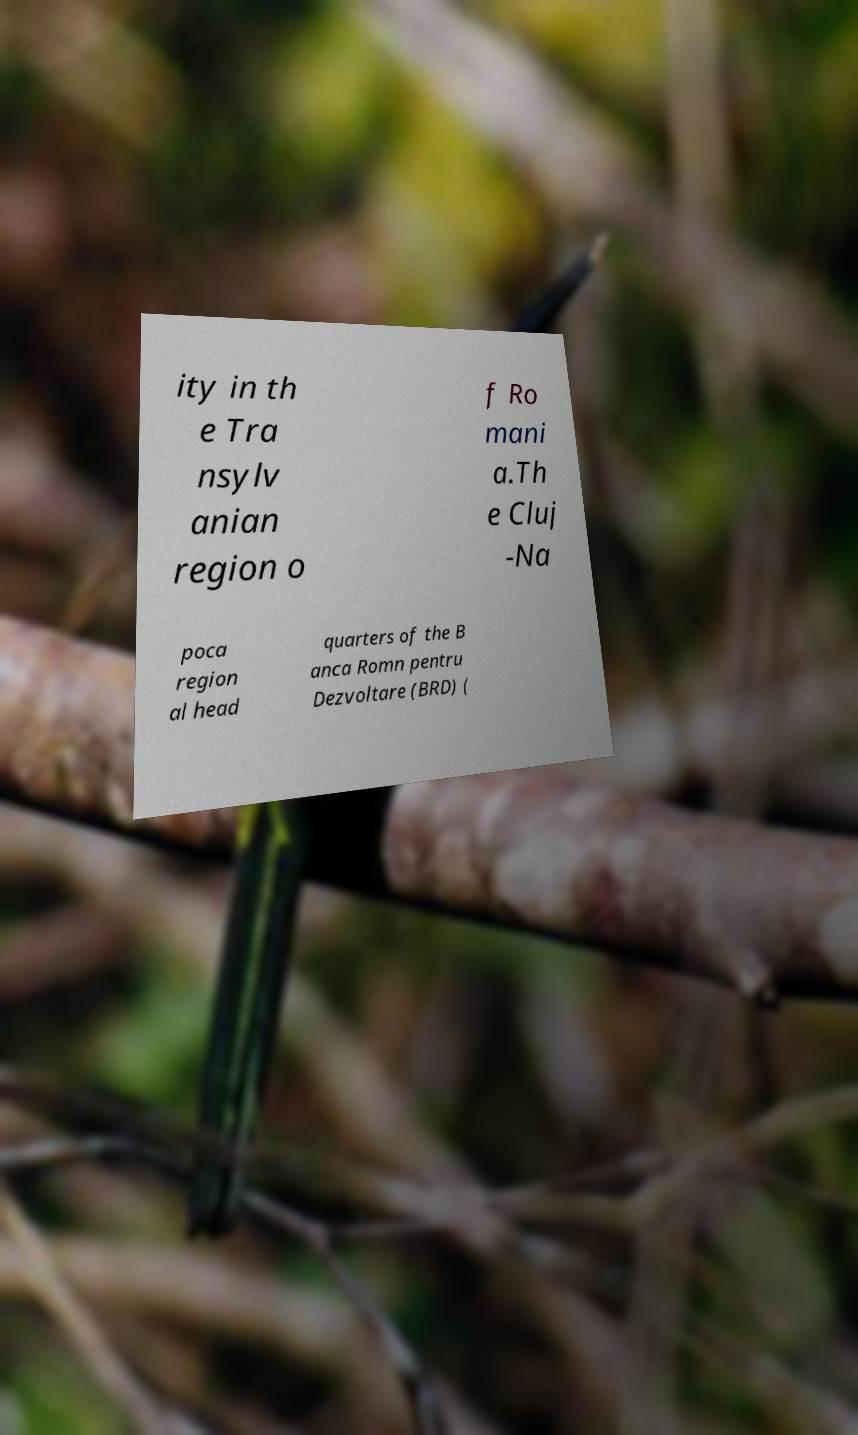Can you accurately transcribe the text from the provided image for me? ity in th e Tra nsylv anian region o f Ro mani a.Th e Cluj -Na poca region al head quarters of the B anca Romn pentru Dezvoltare (BRD) ( 